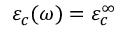<formula> <loc_0><loc_0><loc_500><loc_500>\varepsilon _ { c } ( \omega ) = \varepsilon _ { c } ^ { \infty }</formula> 